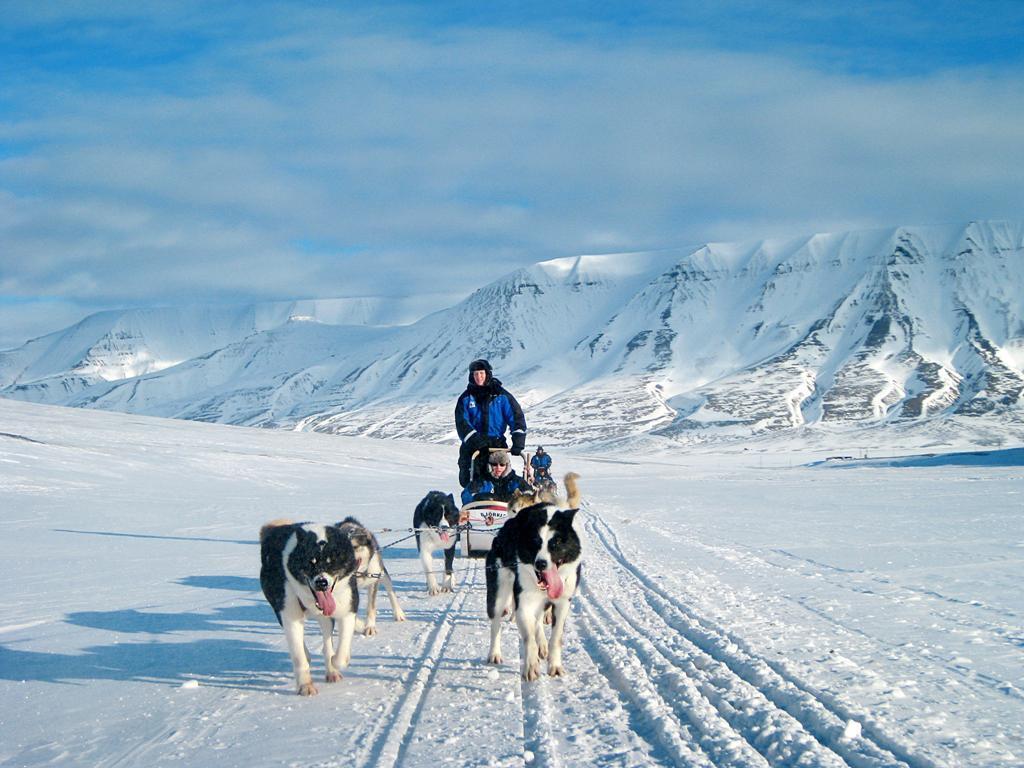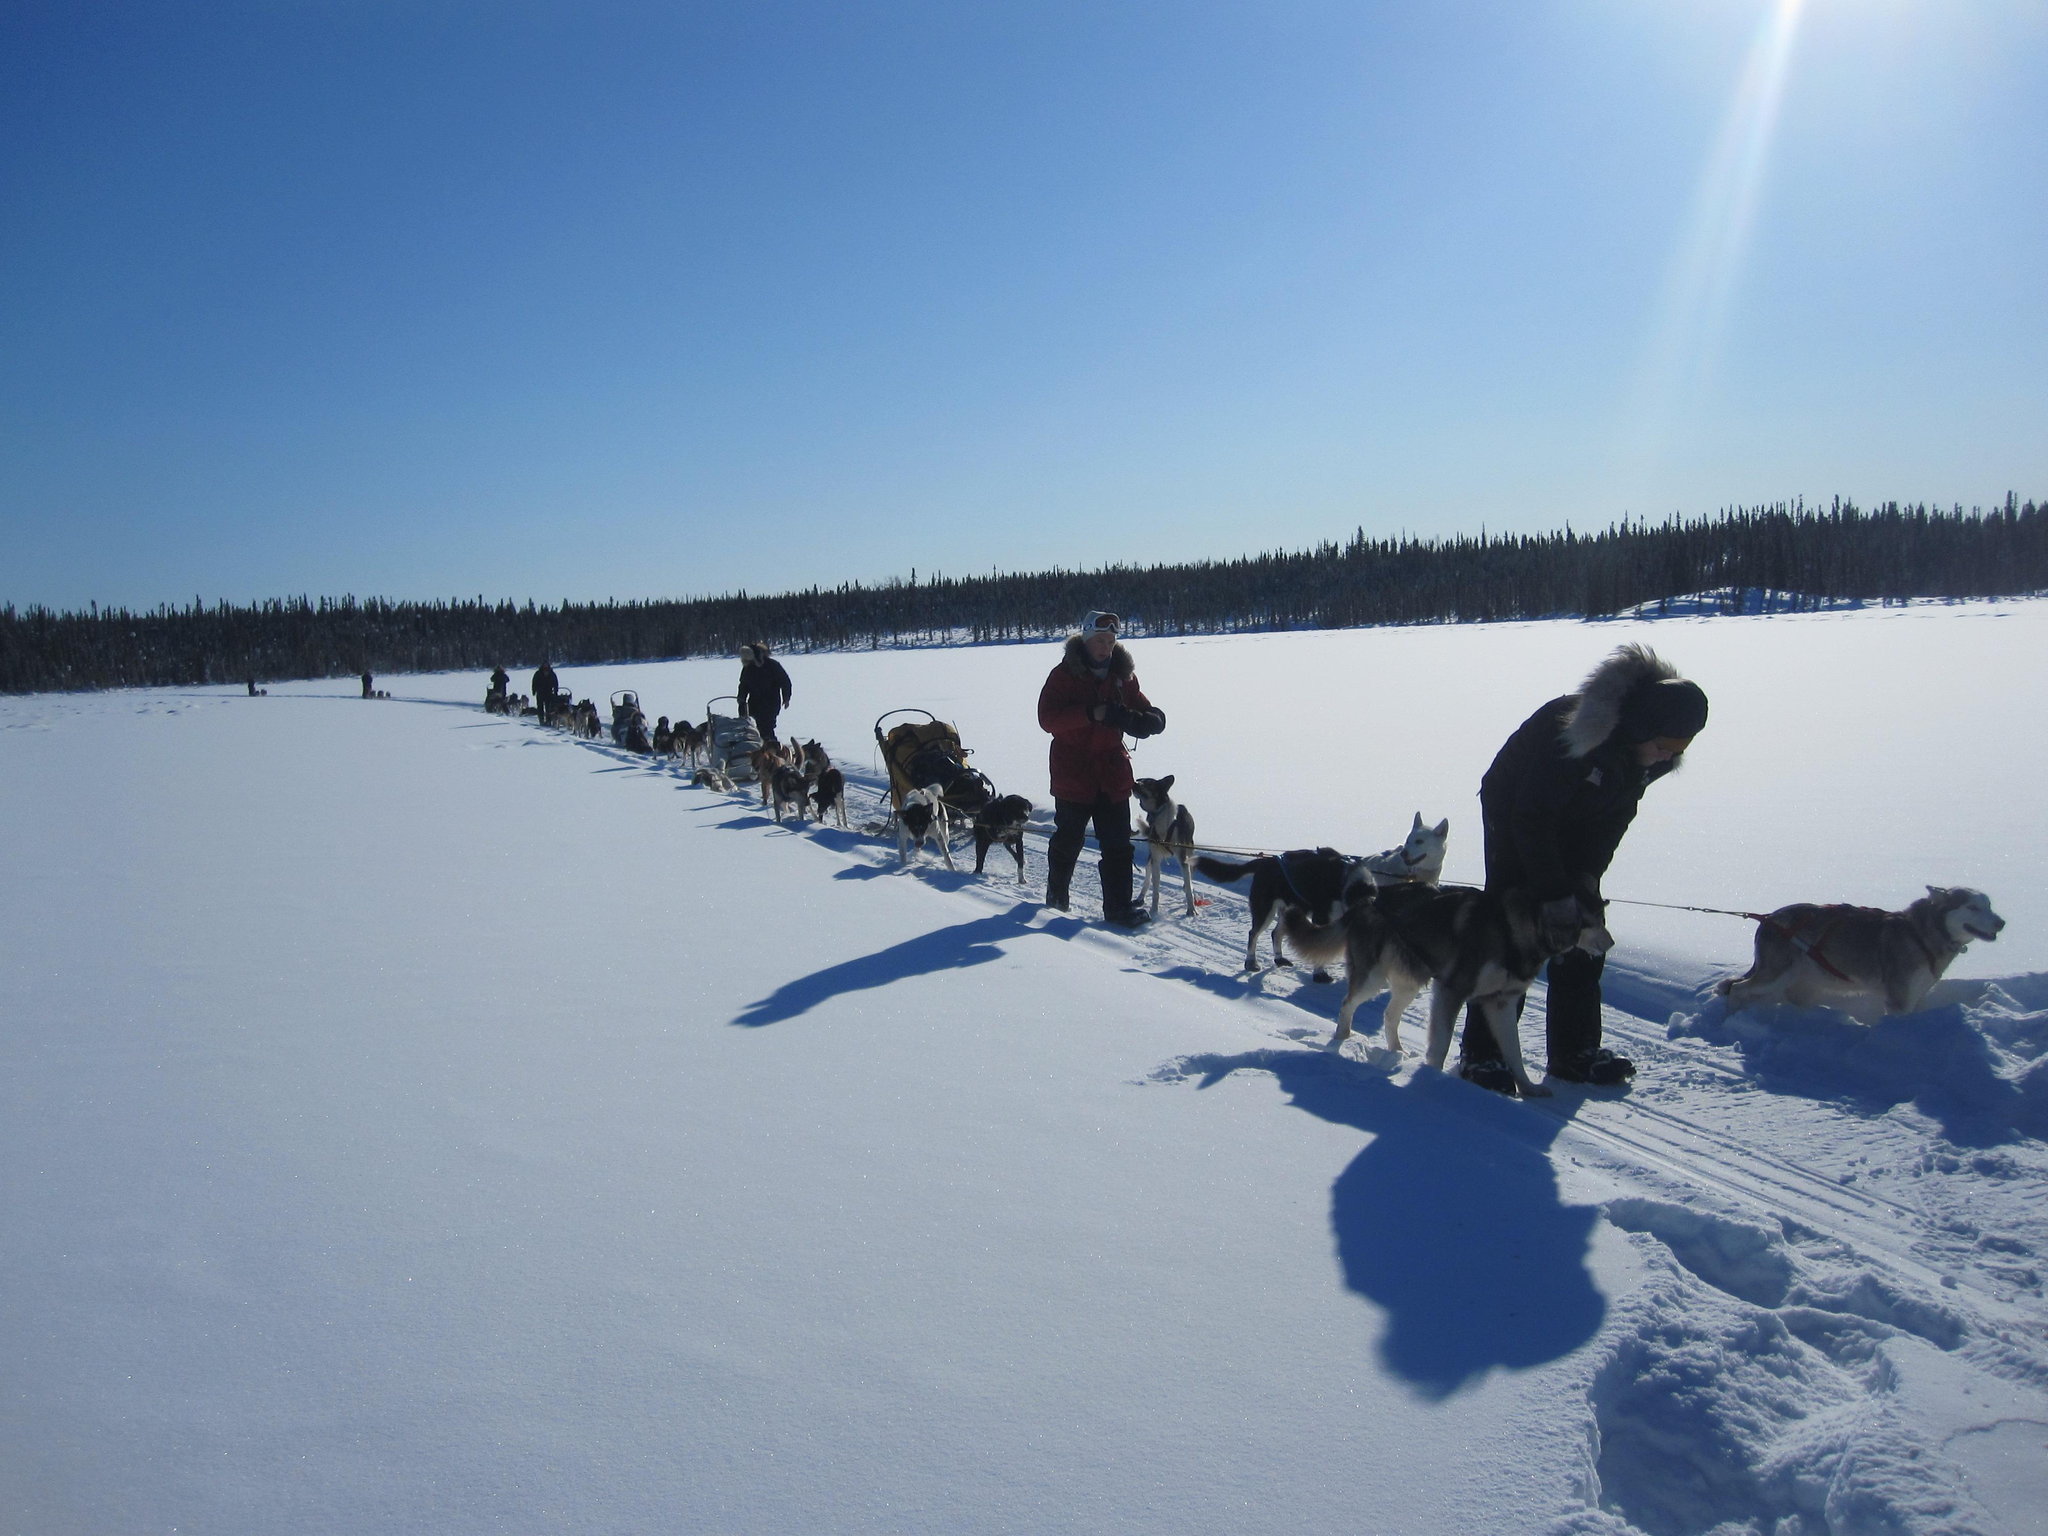The first image is the image on the left, the second image is the image on the right. For the images displayed, is the sentence "One image features a dog team moving horizontally to the right, and the other image features a dog team heading across the snow at a slight angle." factually correct? Answer yes or no. No. The first image is the image on the left, the second image is the image on the right. Analyze the images presented: Is the assertion "There is more than one human visible in at least one of the images." valid? Answer yes or no. Yes. 